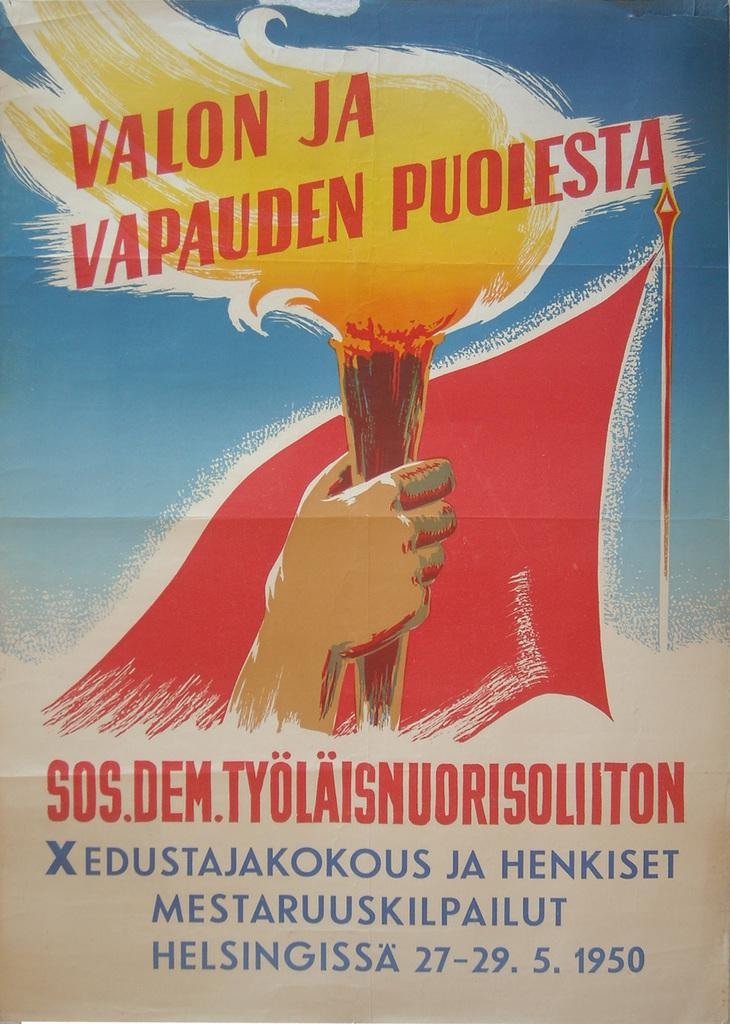<image>
Relay a brief, clear account of the picture shown. A poster advertises an event called Valon Ja Vapauden Puolesta. 